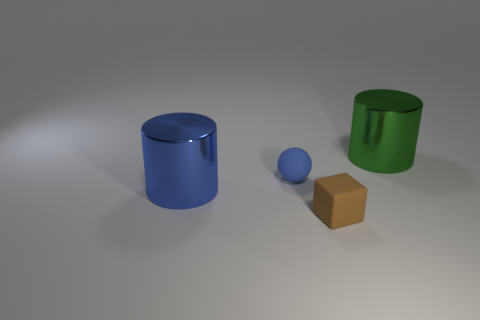There is a tiny matte object in front of the blue rubber sphere; what is its shape?
Give a very brief answer. Cube. Do the small brown matte object and the blue metallic thing have the same shape?
Provide a short and direct response. No. Are there an equal number of cylinders to the left of the green cylinder and small purple things?
Make the answer very short. No. The brown matte object has what shape?
Your answer should be compact. Cube. Are there any other things that are the same color as the rubber block?
Give a very brief answer. No. Do the blue thing behind the blue metal cylinder and the shiny cylinder that is to the right of the small blue matte ball have the same size?
Keep it short and to the point. No. What shape is the small brown rubber object in front of the cylinder in front of the green metallic cylinder?
Offer a terse response. Cube. There is a brown matte thing; is its size the same as the shiny thing to the left of the large green cylinder?
Give a very brief answer. No. What is the size of the metal thing in front of the cylinder that is to the right of the cylinder that is in front of the green shiny object?
Offer a terse response. Large. What number of things are things on the right side of the brown cube or blue rubber things?
Keep it short and to the point. 2. 